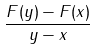<formula> <loc_0><loc_0><loc_500><loc_500>\frac { F ( y ) - F ( x ) } { y - x }</formula> 